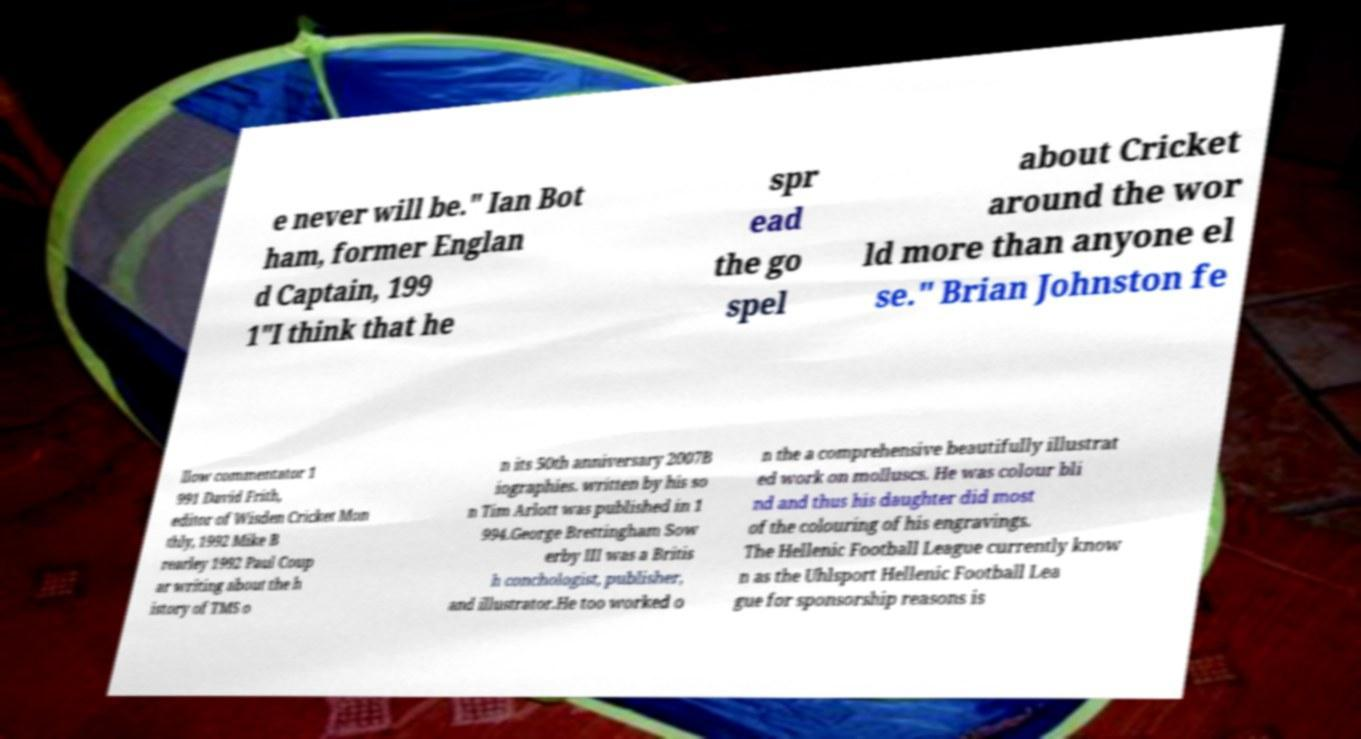Can you accurately transcribe the text from the provided image for me? e never will be." Ian Bot ham, former Englan d Captain, 199 1"I think that he spr ead the go spel about Cricket around the wor ld more than anyone el se." Brian Johnston fe llow commentator 1 991 David Frith, editor of Wisden Cricket Mon thly, 1992 Mike B rearley 1992 Paul Coup ar writing about the h istory of TMS o n its 50th anniversary 2007B iographies. written by his so n Tim Arlott was published in 1 994.George Brettingham Sow erby III was a Britis h conchologist, publisher, and illustrator.He too worked o n the a comprehensive beautifully illustrat ed work on molluscs. He was colour bli nd and thus his daughter did most of the colouring of his engravings. The Hellenic Football League currently know n as the Uhlsport Hellenic Football Lea gue for sponsorship reasons is 